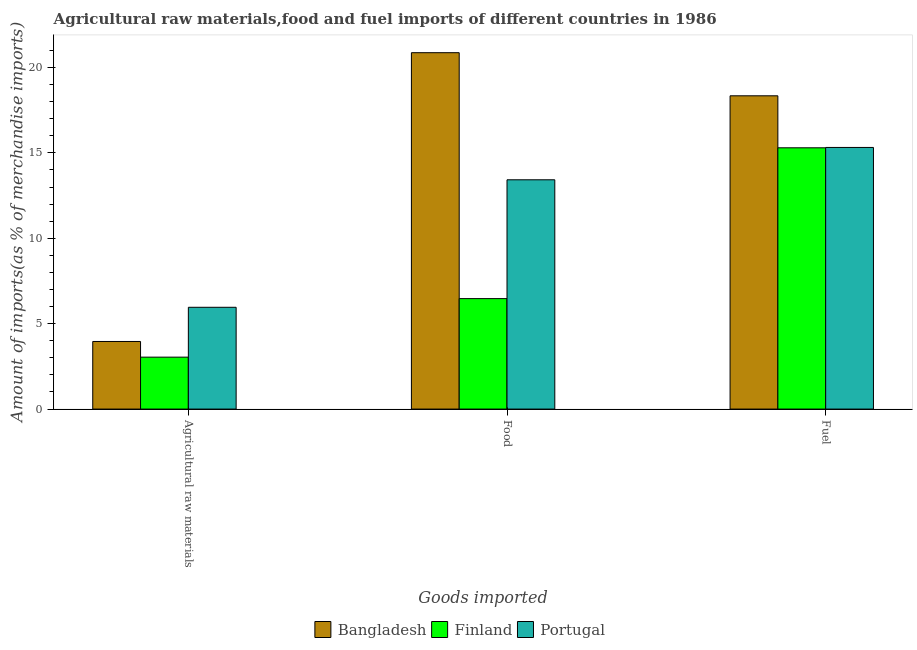What is the label of the 2nd group of bars from the left?
Give a very brief answer. Food. What is the percentage of raw materials imports in Finland?
Keep it short and to the point. 3.04. Across all countries, what is the maximum percentage of raw materials imports?
Your response must be concise. 5.96. Across all countries, what is the minimum percentage of fuel imports?
Your answer should be compact. 15.3. In which country was the percentage of raw materials imports maximum?
Offer a terse response. Portugal. What is the total percentage of raw materials imports in the graph?
Ensure brevity in your answer.  12.96. What is the difference between the percentage of fuel imports in Finland and that in Portugal?
Your answer should be compact. -0.02. What is the difference between the percentage of food imports in Finland and the percentage of raw materials imports in Bangladesh?
Offer a terse response. 2.51. What is the average percentage of food imports per country?
Provide a short and direct response. 13.59. What is the difference between the percentage of fuel imports and percentage of food imports in Bangladesh?
Provide a short and direct response. -2.52. What is the ratio of the percentage of raw materials imports in Portugal to that in Bangladesh?
Provide a short and direct response. 1.51. Is the percentage of food imports in Finland less than that in Bangladesh?
Ensure brevity in your answer.  Yes. Is the difference between the percentage of food imports in Bangladesh and Finland greater than the difference between the percentage of raw materials imports in Bangladesh and Finland?
Provide a short and direct response. Yes. What is the difference between the highest and the second highest percentage of raw materials imports?
Offer a very short reply. 2. What is the difference between the highest and the lowest percentage of fuel imports?
Provide a succinct answer. 3.05. What does the 2nd bar from the left in Fuel represents?
Offer a terse response. Finland. What does the 1st bar from the right in Agricultural raw materials represents?
Provide a succinct answer. Portugal. How many bars are there?
Provide a succinct answer. 9. How many countries are there in the graph?
Make the answer very short. 3. What is the difference between two consecutive major ticks on the Y-axis?
Your answer should be compact. 5. Are the values on the major ticks of Y-axis written in scientific E-notation?
Keep it short and to the point. No. Does the graph contain any zero values?
Offer a very short reply. No. Does the graph contain grids?
Ensure brevity in your answer.  No. Where does the legend appear in the graph?
Offer a terse response. Bottom center. How are the legend labels stacked?
Make the answer very short. Horizontal. What is the title of the graph?
Keep it short and to the point. Agricultural raw materials,food and fuel imports of different countries in 1986. Does "Norway" appear as one of the legend labels in the graph?
Your answer should be compact. No. What is the label or title of the X-axis?
Your response must be concise. Goods imported. What is the label or title of the Y-axis?
Provide a succinct answer. Amount of imports(as % of merchandise imports). What is the Amount of imports(as % of merchandise imports) of Bangladesh in Agricultural raw materials?
Ensure brevity in your answer.  3.96. What is the Amount of imports(as % of merchandise imports) in Finland in Agricultural raw materials?
Ensure brevity in your answer.  3.04. What is the Amount of imports(as % of merchandise imports) of Portugal in Agricultural raw materials?
Keep it short and to the point. 5.96. What is the Amount of imports(as % of merchandise imports) of Bangladesh in Food?
Ensure brevity in your answer.  20.87. What is the Amount of imports(as % of merchandise imports) in Finland in Food?
Keep it short and to the point. 6.47. What is the Amount of imports(as % of merchandise imports) in Portugal in Food?
Ensure brevity in your answer.  13.43. What is the Amount of imports(as % of merchandise imports) of Bangladesh in Fuel?
Provide a succinct answer. 18.34. What is the Amount of imports(as % of merchandise imports) of Finland in Fuel?
Ensure brevity in your answer.  15.3. What is the Amount of imports(as % of merchandise imports) in Portugal in Fuel?
Your response must be concise. 15.32. Across all Goods imported, what is the maximum Amount of imports(as % of merchandise imports) in Bangladesh?
Your answer should be compact. 20.87. Across all Goods imported, what is the maximum Amount of imports(as % of merchandise imports) in Finland?
Ensure brevity in your answer.  15.3. Across all Goods imported, what is the maximum Amount of imports(as % of merchandise imports) of Portugal?
Offer a very short reply. 15.32. Across all Goods imported, what is the minimum Amount of imports(as % of merchandise imports) in Bangladesh?
Make the answer very short. 3.96. Across all Goods imported, what is the minimum Amount of imports(as % of merchandise imports) in Finland?
Your answer should be very brief. 3.04. Across all Goods imported, what is the minimum Amount of imports(as % of merchandise imports) in Portugal?
Ensure brevity in your answer.  5.96. What is the total Amount of imports(as % of merchandise imports) of Bangladesh in the graph?
Make the answer very short. 43.17. What is the total Amount of imports(as % of merchandise imports) in Finland in the graph?
Keep it short and to the point. 24.81. What is the total Amount of imports(as % of merchandise imports) of Portugal in the graph?
Your response must be concise. 34.71. What is the difference between the Amount of imports(as % of merchandise imports) in Bangladesh in Agricultural raw materials and that in Food?
Make the answer very short. -16.91. What is the difference between the Amount of imports(as % of merchandise imports) of Finland in Agricultural raw materials and that in Food?
Keep it short and to the point. -3.43. What is the difference between the Amount of imports(as % of merchandise imports) of Portugal in Agricultural raw materials and that in Food?
Offer a terse response. -7.47. What is the difference between the Amount of imports(as % of merchandise imports) in Bangladesh in Agricultural raw materials and that in Fuel?
Your answer should be very brief. -14.39. What is the difference between the Amount of imports(as % of merchandise imports) in Finland in Agricultural raw materials and that in Fuel?
Your response must be concise. -12.26. What is the difference between the Amount of imports(as % of merchandise imports) in Portugal in Agricultural raw materials and that in Fuel?
Give a very brief answer. -9.36. What is the difference between the Amount of imports(as % of merchandise imports) in Bangladesh in Food and that in Fuel?
Provide a short and direct response. 2.52. What is the difference between the Amount of imports(as % of merchandise imports) in Finland in Food and that in Fuel?
Your response must be concise. -8.83. What is the difference between the Amount of imports(as % of merchandise imports) in Portugal in Food and that in Fuel?
Your answer should be compact. -1.89. What is the difference between the Amount of imports(as % of merchandise imports) of Bangladesh in Agricultural raw materials and the Amount of imports(as % of merchandise imports) of Finland in Food?
Offer a terse response. -2.51. What is the difference between the Amount of imports(as % of merchandise imports) of Bangladesh in Agricultural raw materials and the Amount of imports(as % of merchandise imports) of Portugal in Food?
Ensure brevity in your answer.  -9.47. What is the difference between the Amount of imports(as % of merchandise imports) of Finland in Agricultural raw materials and the Amount of imports(as % of merchandise imports) of Portugal in Food?
Offer a very short reply. -10.39. What is the difference between the Amount of imports(as % of merchandise imports) of Bangladesh in Agricultural raw materials and the Amount of imports(as % of merchandise imports) of Finland in Fuel?
Keep it short and to the point. -11.34. What is the difference between the Amount of imports(as % of merchandise imports) in Bangladesh in Agricultural raw materials and the Amount of imports(as % of merchandise imports) in Portugal in Fuel?
Offer a very short reply. -11.36. What is the difference between the Amount of imports(as % of merchandise imports) in Finland in Agricultural raw materials and the Amount of imports(as % of merchandise imports) in Portugal in Fuel?
Make the answer very short. -12.28. What is the difference between the Amount of imports(as % of merchandise imports) in Bangladesh in Food and the Amount of imports(as % of merchandise imports) in Finland in Fuel?
Your response must be concise. 5.57. What is the difference between the Amount of imports(as % of merchandise imports) in Bangladesh in Food and the Amount of imports(as % of merchandise imports) in Portugal in Fuel?
Offer a terse response. 5.55. What is the difference between the Amount of imports(as % of merchandise imports) in Finland in Food and the Amount of imports(as % of merchandise imports) in Portugal in Fuel?
Your answer should be very brief. -8.85. What is the average Amount of imports(as % of merchandise imports) of Bangladesh per Goods imported?
Make the answer very short. 14.39. What is the average Amount of imports(as % of merchandise imports) of Finland per Goods imported?
Offer a very short reply. 8.27. What is the average Amount of imports(as % of merchandise imports) of Portugal per Goods imported?
Your answer should be very brief. 11.57. What is the difference between the Amount of imports(as % of merchandise imports) in Bangladesh and Amount of imports(as % of merchandise imports) in Finland in Agricultural raw materials?
Offer a very short reply. 0.92. What is the difference between the Amount of imports(as % of merchandise imports) in Bangladesh and Amount of imports(as % of merchandise imports) in Portugal in Agricultural raw materials?
Provide a succinct answer. -2. What is the difference between the Amount of imports(as % of merchandise imports) in Finland and Amount of imports(as % of merchandise imports) in Portugal in Agricultural raw materials?
Your answer should be very brief. -2.92. What is the difference between the Amount of imports(as % of merchandise imports) in Bangladesh and Amount of imports(as % of merchandise imports) in Finland in Food?
Offer a very short reply. 14.4. What is the difference between the Amount of imports(as % of merchandise imports) in Bangladesh and Amount of imports(as % of merchandise imports) in Portugal in Food?
Keep it short and to the point. 7.44. What is the difference between the Amount of imports(as % of merchandise imports) in Finland and Amount of imports(as % of merchandise imports) in Portugal in Food?
Your answer should be very brief. -6.96. What is the difference between the Amount of imports(as % of merchandise imports) in Bangladesh and Amount of imports(as % of merchandise imports) in Finland in Fuel?
Provide a short and direct response. 3.05. What is the difference between the Amount of imports(as % of merchandise imports) in Bangladesh and Amount of imports(as % of merchandise imports) in Portugal in Fuel?
Ensure brevity in your answer.  3.02. What is the difference between the Amount of imports(as % of merchandise imports) in Finland and Amount of imports(as % of merchandise imports) in Portugal in Fuel?
Provide a short and direct response. -0.02. What is the ratio of the Amount of imports(as % of merchandise imports) of Bangladesh in Agricultural raw materials to that in Food?
Ensure brevity in your answer.  0.19. What is the ratio of the Amount of imports(as % of merchandise imports) in Finland in Agricultural raw materials to that in Food?
Ensure brevity in your answer.  0.47. What is the ratio of the Amount of imports(as % of merchandise imports) of Portugal in Agricultural raw materials to that in Food?
Provide a short and direct response. 0.44. What is the ratio of the Amount of imports(as % of merchandise imports) in Bangladesh in Agricultural raw materials to that in Fuel?
Your answer should be very brief. 0.22. What is the ratio of the Amount of imports(as % of merchandise imports) of Finland in Agricultural raw materials to that in Fuel?
Make the answer very short. 0.2. What is the ratio of the Amount of imports(as % of merchandise imports) of Portugal in Agricultural raw materials to that in Fuel?
Your response must be concise. 0.39. What is the ratio of the Amount of imports(as % of merchandise imports) of Bangladesh in Food to that in Fuel?
Make the answer very short. 1.14. What is the ratio of the Amount of imports(as % of merchandise imports) of Finland in Food to that in Fuel?
Keep it short and to the point. 0.42. What is the ratio of the Amount of imports(as % of merchandise imports) of Portugal in Food to that in Fuel?
Ensure brevity in your answer.  0.88. What is the difference between the highest and the second highest Amount of imports(as % of merchandise imports) in Bangladesh?
Your answer should be compact. 2.52. What is the difference between the highest and the second highest Amount of imports(as % of merchandise imports) of Finland?
Keep it short and to the point. 8.83. What is the difference between the highest and the second highest Amount of imports(as % of merchandise imports) of Portugal?
Your answer should be compact. 1.89. What is the difference between the highest and the lowest Amount of imports(as % of merchandise imports) of Bangladesh?
Make the answer very short. 16.91. What is the difference between the highest and the lowest Amount of imports(as % of merchandise imports) in Finland?
Keep it short and to the point. 12.26. What is the difference between the highest and the lowest Amount of imports(as % of merchandise imports) of Portugal?
Provide a short and direct response. 9.36. 